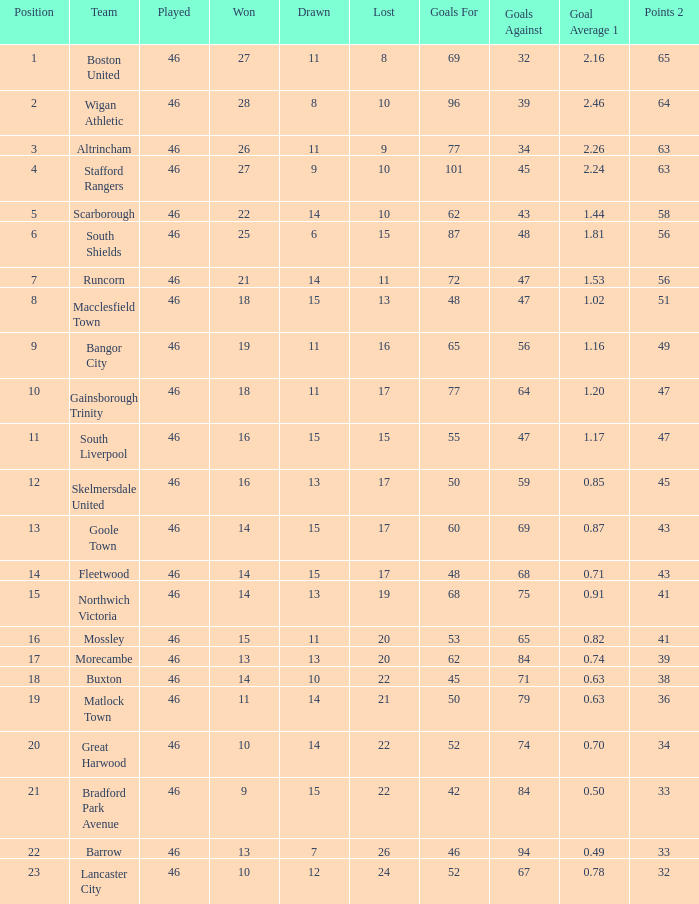How many winning games did the team with 60 goals achieve? 14.0. 